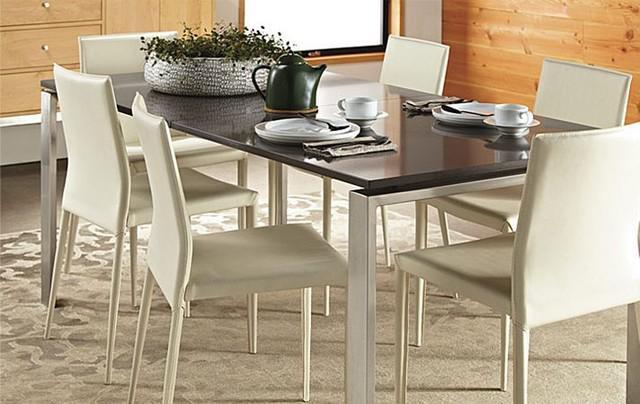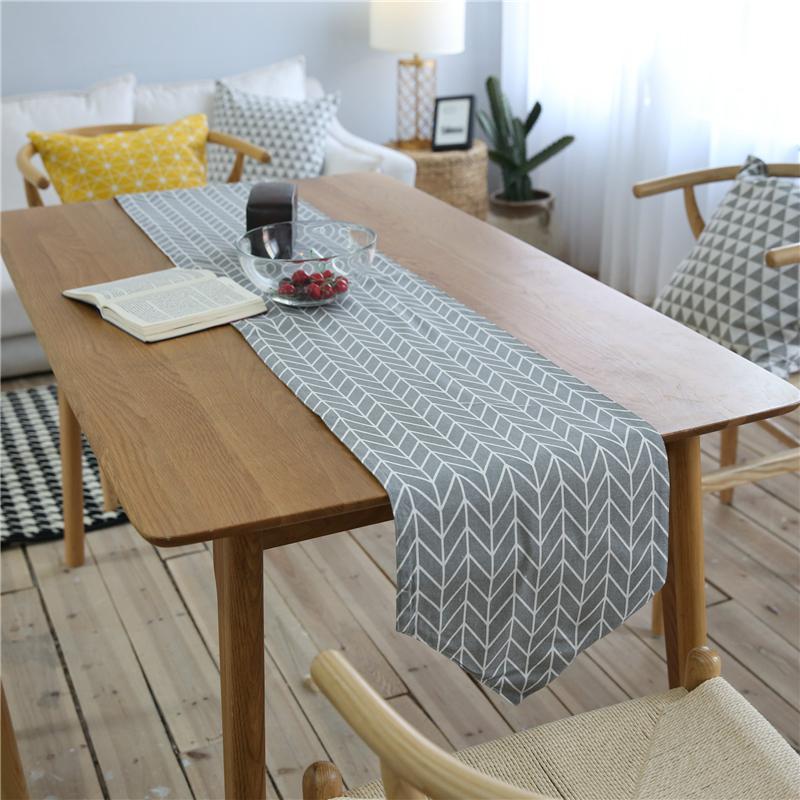The first image is the image on the left, the second image is the image on the right. Given the left and right images, does the statement "There is a white hanging lamp over the table in at least one of the images." hold true? Answer yes or no. No. 